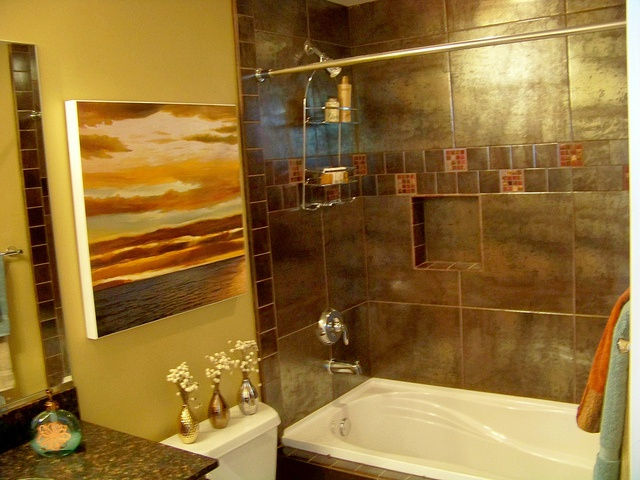Describe the objects in this image and their specific colors. I can see toilet in olive, tan, and khaki tones, bottle in olive, orange, and black tones, potted plant in olive and tan tones, potted plant in olive, tan, and khaki tones, and potted plant in olive, tan, and maroon tones in this image. 